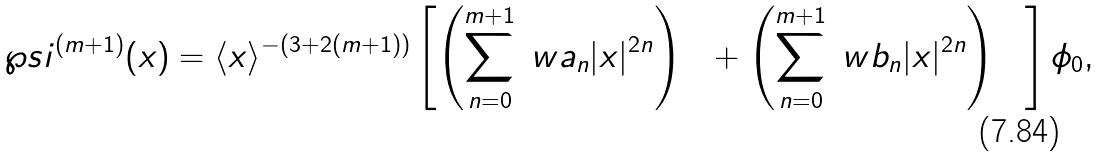<formula> <loc_0><loc_0><loc_500><loc_500>\wp s i ^ { ( m + 1 ) } ( x ) = \langle x \rangle ^ { - ( 3 + 2 ( m + 1 ) ) } \left [ \left ( \sum _ { n = 0 } ^ { m + 1 } \ w a _ { n } | x | ^ { 2 n } \right ) { \mathbf 1 } + \left ( \sum _ { n = 0 } ^ { m + 1 } \ w b _ { n } | x | ^ { 2 n } \right ) { \mathbf X } \right ] \phi _ { 0 } ,</formula> 